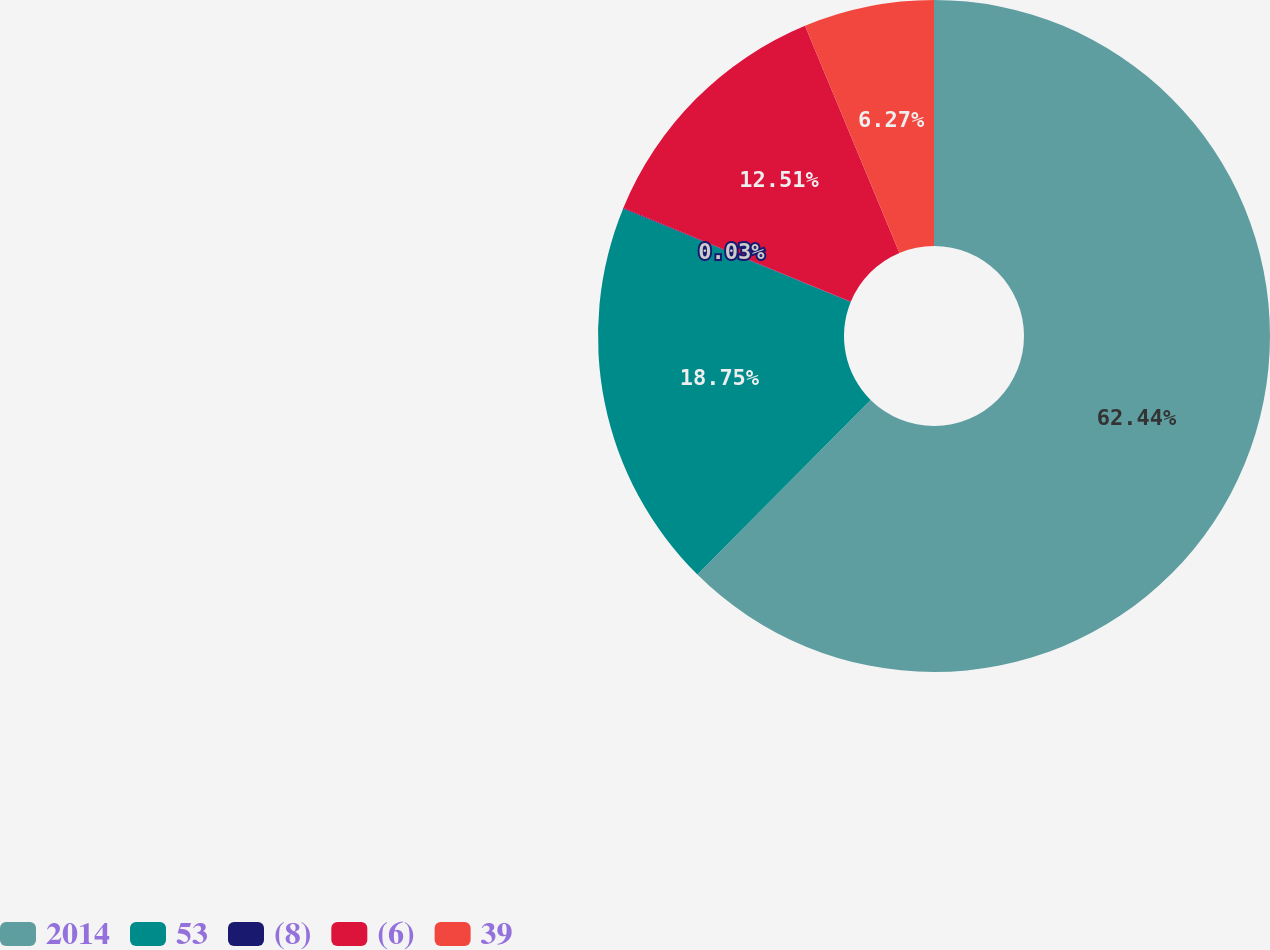<chart> <loc_0><loc_0><loc_500><loc_500><pie_chart><fcel>2014<fcel>53<fcel>(8)<fcel>(6)<fcel>39<nl><fcel>62.43%<fcel>18.75%<fcel>0.03%<fcel>12.51%<fcel>6.27%<nl></chart> 